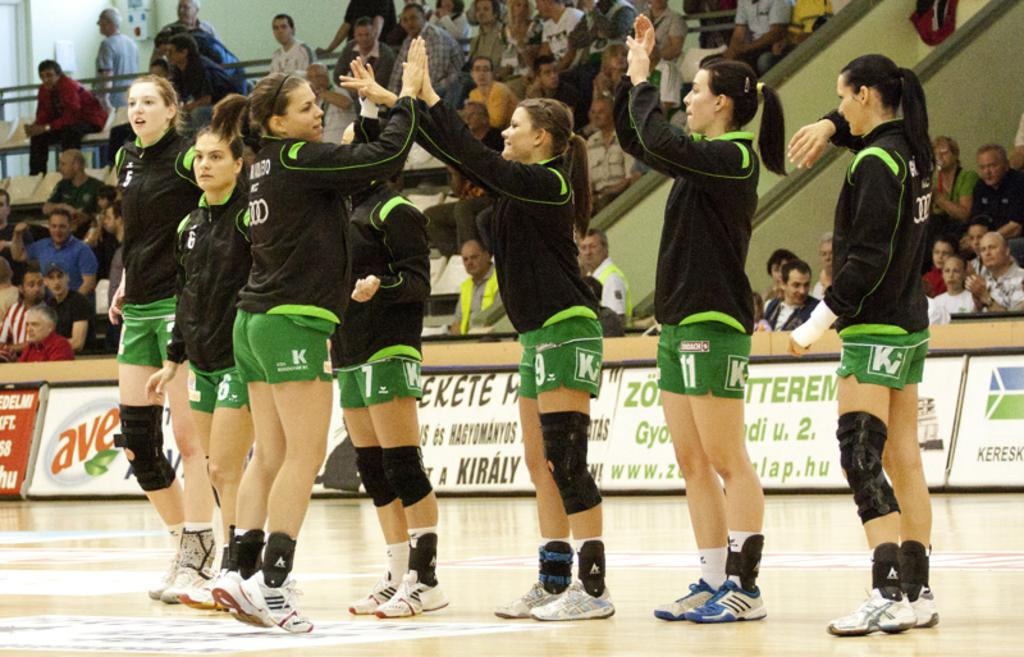<image>
Offer a succinct explanation of the picture presented. A voleyball team of girls wearing green shorts with the letter K on them 